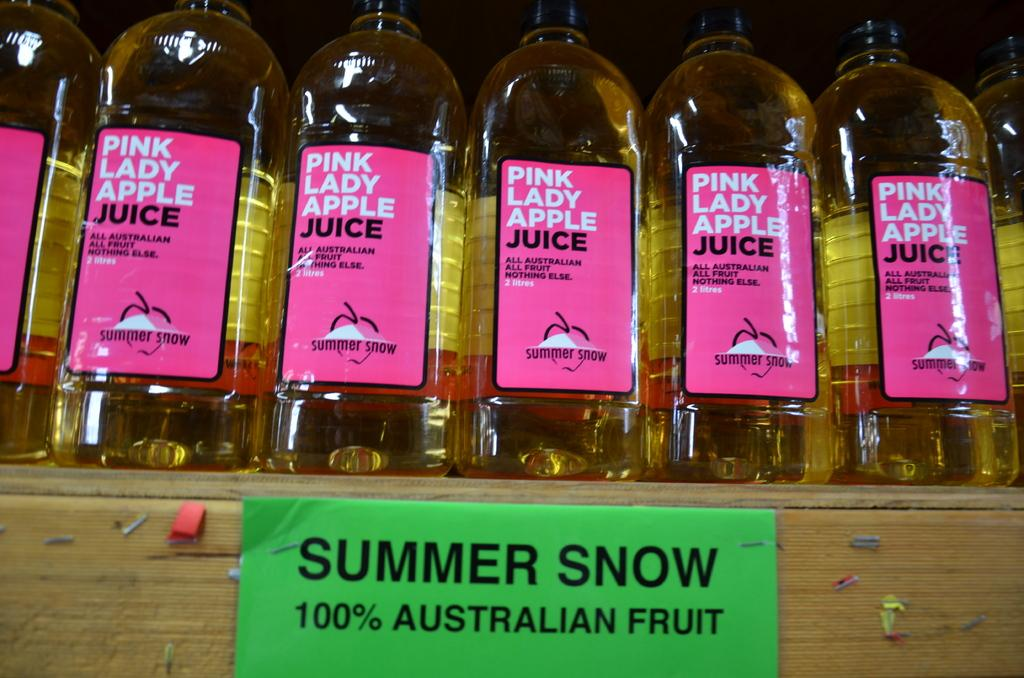Provide a one-sentence caption for the provided image. Seven bottles of Pink Lady Apple juice are lined up neatly on a shelf. 